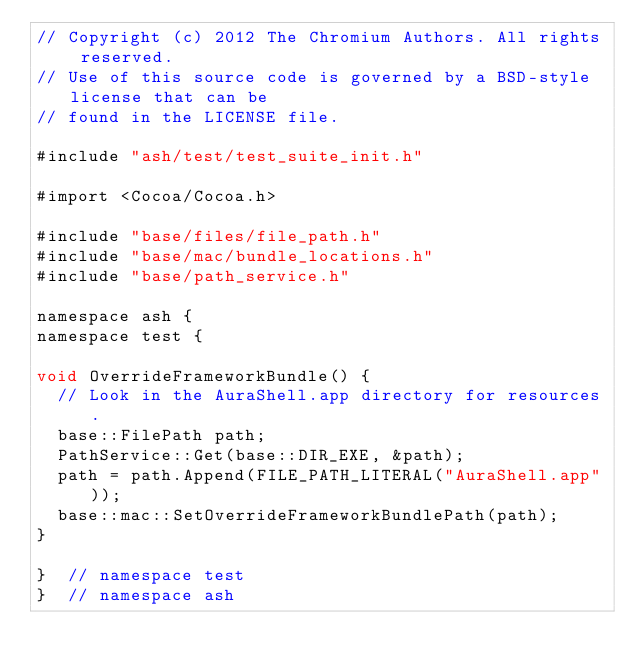Convert code to text. <code><loc_0><loc_0><loc_500><loc_500><_ObjectiveC_>// Copyright (c) 2012 The Chromium Authors. All rights reserved.
// Use of this source code is governed by a BSD-style license that can be
// found in the LICENSE file.

#include "ash/test/test_suite_init.h"

#import <Cocoa/Cocoa.h>

#include "base/files/file_path.h"
#include "base/mac/bundle_locations.h"
#include "base/path_service.h"

namespace ash {
namespace test {

void OverrideFrameworkBundle() {
  // Look in the AuraShell.app directory for resources.
  base::FilePath path;
  PathService::Get(base::DIR_EXE, &path);
  path = path.Append(FILE_PATH_LITERAL("AuraShell.app"));
  base::mac::SetOverrideFrameworkBundlePath(path);
}

}  // namespace test
}  // namespace ash
</code> 